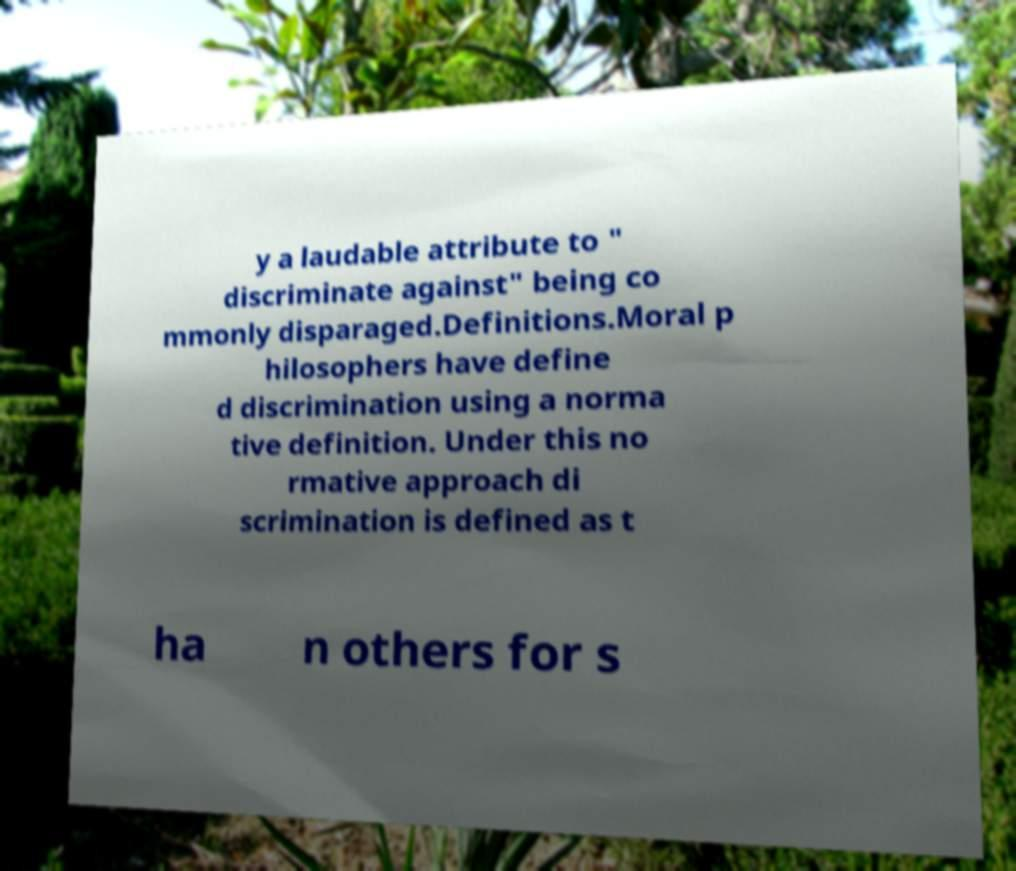Can you accurately transcribe the text from the provided image for me? y a laudable attribute to " discriminate against" being co mmonly disparaged.Definitions.Moral p hilosophers have define d discrimination using a norma tive definition. Under this no rmative approach di scrimination is defined as t ha n others for s 